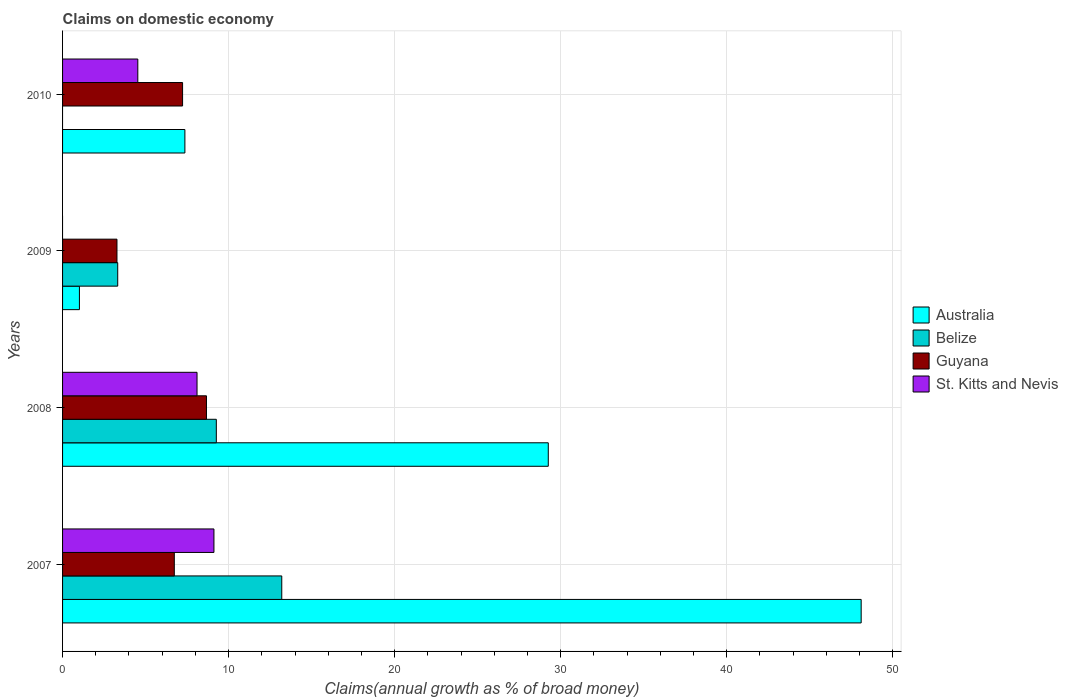Are the number of bars per tick equal to the number of legend labels?
Give a very brief answer. No. How many bars are there on the 4th tick from the top?
Your response must be concise. 4. How many bars are there on the 4th tick from the bottom?
Offer a very short reply. 3. What is the label of the 3rd group of bars from the top?
Your answer should be very brief. 2008. What is the percentage of broad money claimed on domestic economy in Belize in 2008?
Your answer should be very brief. 9.26. Across all years, what is the maximum percentage of broad money claimed on domestic economy in Guyana?
Provide a succinct answer. 8.67. Across all years, what is the minimum percentage of broad money claimed on domestic economy in Belize?
Offer a very short reply. 0. What is the total percentage of broad money claimed on domestic economy in Guyana in the graph?
Keep it short and to the point. 25.9. What is the difference between the percentage of broad money claimed on domestic economy in St. Kitts and Nevis in 2008 and that in 2010?
Your response must be concise. 3.57. What is the difference between the percentage of broad money claimed on domestic economy in Australia in 2008 and the percentage of broad money claimed on domestic economy in St. Kitts and Nevis in 2007?
Keep it short and to the point. 20.14. What is the average percentage of broad money claimed on domestic economy in St. Kitts and Nevis per year?
Your answer should be compact. 5.44. In the year 2007, what is the difference between the percentage of broad money claimed on domestic economy in St. Kitts and Nevis and percentage of broad money claimed on domestic economy in Australia?
Your response must be concise. -38.98. What is the ratio of the percentage of broad money claimed on domestic economy in Australia in 2007 to that in 2009?
Your answer should be compact. 47.4. Is the percentage of broad money claimed on domestic economy in Guyana in 2009 less than that in 2010?
Ensure brevity in your answer.  Yes. What is the difference between the highest and the second highest percentage of broad money claimed on domestic economy in Belize?
Keep it short and to the point. 3.94. What is the difference between the highest and the lowest percentage of broad money claimed on domestic economy in Belize?
Offer a very short reply. 13.2. In how many years, is the percentage of broad money claimed on domestic economy in Guyana greater than the average percentage of broad money claimed on domestic economy in Guyana taken over all years?
Your response must be concise. 3. Is it the case that in every year, the sum of the percentage of broad money claimed on domestic economy in Guyana and percentage of broad money claimed on domestic economy in St. Kitts and Nevis is greater than the sum of percentage of broad money claimed on domestic economy in Australia and percentage of broad money claimed on domestic economy in Belize?
Offer a terse response. No. Is it the case that in every year, the sum of the percentage of broad money claimed on domestic economy in Guyana and percentage of broad money claimed on domestic economy in St. Kitts and Nevis is greater than the percentage of broad money claimed on domestic economy in Belize?
Your answer should be very brief. No. How many bars are there?
Keep it short and to the point. 14. How many years are there in the graph?
Keep it short and to the point. 4. Are the values on the major ticks of X-axis written in scientific E-notation?
Ensure brevity in your answer.  No. How many legend labels are there?
Provide a succinct answer. 4. How are the legend labels stacked?
Give a very brief answer. Vertical. What is the title of the graph?
Provide a succinct answer. Claims on domestic economy. What is the label or title of the X-axis?
Offer a terse response. Claims(annual growth as % of broad money). What is the Claims(annual growth as % of broad money) of Australia in 2007?
Your answer should be compact. 48.1. What is the Claims(annual growth as % of broad money) of Belize in 2007?
Your answer should be very brief. 13.2. What is the Claims(annual growth as % of broad money) in Guyana in 2007?
Make the answer very short. 6.73. What is the Claims(annual growth as % of broad money) of St. Kitts and Nevis in 2007?
Your answer should be compact. 9.12. What is the Claims(annual growth as % of broad money) in Australia in 2008?
Make the answer very short. 29.25. What is the Claims(annual growth as % of broad money) of Belize in 2008?
Your response must be concise. 9.26. What is the Claims(annual growth as % of broad money) in Guyana in 2008?
Offer a terse response. 8.67. What is the Claims(annual growth as % of broad money) of St. Kitts and Nevis in 2008?
Keep it short and to the point. 8.1. What is the Claims(annual growth as % of broad money) in Australia in 2009?
Provide a short and direct response. 1.01. What is the Claims(annual growth as % of broad money) of Belize in 2009?
Provide a succinct answer. 3.32. What is the Claims(annual growth as % of broad money) of Guyana in 2009?
Provide a short and direct response. 3.28. What is the Claims(annual growth as % of broad money) of St. Kitts and Nevis in 2009?
Keep it short and to the point. 0. What is the Claims(annual growth as % of broad money) in Australia in 2010?
Provide a succinct answer. 7.37. What is the Claims(annual growth as % of broad money) of Belize in 2010?
Make the answer very short. 0. What is the Claims(annual growth as % of broad money) in Guyana in 2010?
Offer a terse response. 7.23. What is the Claims(annual growth as % of broad money) of St. Kitts and Nevis in 2010?
Make the answer very short. 4.53. Across all years, what is the maximum Claims(annual growth as % of broad money) in Australia?
Give a very brief answer. 48.1. Across all years, what is the maximum Claims(annual growth as % of broad money) in Belize?
Offer a very short reply. 13.2. Across all years, what is the maximum Claims(annual growth as % of broad money) in Guyana?
Your answer should be very brief. 8.67. Across all years, what is the maximum Claims(annual growth as % of broad money) in St. Kitts and Nevis?
Give a very brief answer. 9.12. Across all years, what is the minimum Claims(annual growth as % of broad money) of Australia?
Offer a terse response. 1.01. Across all years, what is the minimum Claims(annual growth as % of broad money) in Belize?
Your answer should be very brief. 0. Across all years, what is the minimum Claims(annual growth as % of broad money) of Guyana?
Your response must be concise. 3.28. What is the total Claims(annual growth as % of broad money) of Australia in the graph?
Give a very brief answer. 85.73. What is the total Claims(annual growth as % of broad money) of Belize in the graph?
Offer a terse response. 25.78. What is the total Claims(annual growth as % of broad money) in Guyana in the graph?
Provide a short and direct response. 25.9. What is the total Claims(annual growth as % of broad money) in St. Kitts and Nevis in the graph?
Keep it short and to the point. 21.75. What is the difference between the Claims(annual growth as % of broad money) of Australia in 2007 and that in 2008?
Keep it short and to the point. 18.84. What is the difference between the Claims(annual growth as % of broad money) of Belize in 2007 and that in 2008?
Offer a very short reply. 3.94. What is the difference between the Claims(annual growth as % of broad money) in Guyana in 2007 and that in 2008?
Your answer should be very brief. -1.94. What is the difference between the Claims(annual growth as % of broad money) of St. Kitts and Nevis in 2007 and that in 2008?
Give a very brief answer. 1.02. What is the difference between the Claims(annual growth as % of broad money) in Australia in 2007 and that in 2009?
Offer a terse response. 47.08. What is the difference between the Claims(annual growth as % of broad money) in Belize in 2007 and that in 2009?
Provide a short and direct response. 9.88. What is the difference between the Claims(annual growth as % of broad money) of Guyana in 2007 and that in 2009?
Provide a short and direct response. 3.45. What is the difference between the Claims(annual growth as % of broad money) in Australia in 2007 and that in 2010?
Give a very brief answer. 40.73. What is the difference between the Claims(annual growth as % of broad money) of Guyana in 2007 and that in 2010?
Your response must be concise. -0.5. What is the difference between the Claims(annual growth as % of broad money) in St. Kitts and Nevis in 2007 and that in 2010?
Keep it short and to the point. 4.59. What is the difference between the Claims(annual growth as % of broad money) of Australia in 2008 and that in 2009?
Your answer should be very brief. 28.24. What is the difference between the Claims(annual growth as % of broad money) of Belize in 2008 and that in 2009?
Keep it short and to the point. 5.94. What is the difference between the Claims(annual growth as % of broad money) of Guyana in 2008 and that in 2009?
Offer a terse response. 5.39. What is the difference between the Claims(annual growth as % of broad money) of Australia in 2008 and that in 2010?
Your response must be concise. 21.89. What is the difference between the Claims(annual growth as % of broad money) of Guyana in 2008 and that in 2010?
Give a very brief answer. 1.44. What is the difference between the Claims(annual growth as % of broad money) of St. Kitts and Nevis in 2008 and that in 2010?
Keep it short and to the point. 3.57. What is the difference between the Claims(annual growth as % of broad money) in Australia in 2009 and that in 2010?
Your answer should be compact. -6.35. What is the difference between the Claims(annual growth as % of broad money) of Guyana in 2009 and that in 2010?
Make the answer very short. -3.95. What is the difference between the Claims(annual growth as % of broad money) of Australia in 2007 and the Claims(annual growth as % of broad money) of Belize in 2008?
Offer a very short reply. 38.84. What is the difference between the Claims(annual growth as % of broad money) of Australia in 2007 and the Claims(annual growth as % of broad money) of Guyana in 2008?
Your response must be concise. 39.43. What is the difference between the Claims(annual growth as % of broad money) in Australia in 2007 and the Claims(annual growth as % of broad money) in St. Kitts and Nevis in 2008?
Provide a succinct answer. 40. What is the difference between the Claims(annual growth as % of broad money) of Belize in 2007 and the Claims(annual growth as % of broad money) of Guyana in 2008?
Give a very brief answer. 4.54. What is the difference between the Claims(annual growth as % of broad money) of Belize in 2007 and the Claims(annual growth as % of broad money) of St. Kitts and Nevis in 2008?
Your answer should be compact. 5.1. What is the difference between the Claims(annual growth as % of broad money) of Guyana in 2007 and the Claims(annual growth as % of broad money) of St. Kitts and Nevis in 2008?
Your answer should be compact. -1.37. What is the difference between the Claims(annual growth as % of broad money) in Australia in 2007 and the Claims(annual growth as % of broad money) in Belize in 2009?
Provide a succinct answer. 44.77. What is the difference between the Claims(annual growth as % of broad money) of Australia in 2007 and the Claims(annual growth as % of broad money) of Guyana in 2009?
Give a very brief answer. 44.82. What is the difference between the Claims(annual growth as % of broad money) of Belize in 2007 and the Claims(annual growth as % of broad money) of Guyana in 2009?
Make the answer very short. 9.93. What is the difference between the Claims(annual growth as % of broad money) in Australia in 2007 and the Claims(annual growth as % of broad money) in Guyana in 2010?
Your response must be concise. 40.87. What is the difference between the Claims(annual growth as % of broad money) of Australia in 2007 and the Claims(annual growth as % of broad money) of St. Kitts and Nevis in 2010?
Offer a terse response. 43.56. What is the difference between the Claims(annual growth as % of broad money) of Belize in 2007 and the Claims(annual growth as % of broad money) of Guyana in 2010?
Your answer should be very brief. 5.97. What is the difference between the Claims(annual growth as % of broad money) in Belize in 2007 and the Claims(annual growth as % of broad money) in St. Kitts and Nevis in 2010?
Your response must be concise. 8.67. What is the difference between the Claims(annual growth as % of broad money) of Guyana in 2007 and the Claims(annual growth as % of broad money) of St. Kitts and Nevis in 2010?
Offer a very short reply. 2.2. What is the difference between the Claims(annual growth as % of broad money) in Australia in 2008 and the Claims(annual growth as % of broad money) in Belize in 2009?
Ensure brevity in your answer.  25.93. What is the difference between the Claims(annual growth as % of broad money) of Australia in 2008 and the Claims(annual growth as % of broad money) of Guyana in 2009?
Give a very brief answer. 25.98. What is the difference between the Claims(annual growth as % of broad money) of Belize in 2008 and the Claims(annual growth as % of broad money) of Guyana in 2009?
Your answer should be very brief. 5.98. What is the difference between the Claims(annual growth as % of broad money) in Australia in 2008 and the Claims(annual growth as % of broad money) in Guyana in 2010?
Your answer should be compact. 22.02. What is the difference between the Claims(annual growth as % of broad money) of Australia in 2008 and the Claims(annual growth as % of broad money) of St. Kitts and Nevis in 2010?
Provide a short and direct response. 24.72. What is the difference between the Claims(annual growth as % of broad money) of Belize in 2008 and the Claims(annual growth as % of broad money) of Guyana in 2010?
Offer a terse response. 2.03. What is the difference between the Claims(annual growth as % of broad money) in Belize in 2008 and the Claims(annual growth as % of broad money) in St. Kitts and Nevis in 2010?
Your answer should be very brief. 4.73. What is the difference between the Claims(annual growth as % of broad money) in Guyana in 2008 and the Claims(annual growth as % of broad money) in St. Kitts and Nevis in 2010?
Your response must be concise. 4.13. What is the difference between the Claims(annual growth as % of broad money) in Australia in 2009 and the Claims(annual growth as % of broad money) in Guyana in 2010?
Keep it short and to the point. -6.21. What is the difference between the Claims(annual growth as % of broad money) in Australia in 2009 and the Claims(annual growth as % of broad money) in St. Kitts and Nevis in 2010?
Keep it short and to the point. -3.52. What is the difference between the Claims(annual growth as % of broad money) in Belize in 2009 and the Claims(annual growth as % of broad money) in Guyana in 2010?
Ensure brevity in your answer.  -3.91. What is the difference between the Claims(annual growth as % of broad money) in Belize in 2009 and the Claims(annual growth as % of broad money) in St. Kitts and Nevis in 2010?
Your answer should be compact. -1.21. What is the difference between the Claims(annual growth as % of broad money) in Guyana in 2009 and the Claims(annual growth as % of broad money) in St. Kitts and Nevis in 2010?
Keep it short and to the point. -1.26. What is the average Claims(annual growth as % of broad money) of Australia per year?
Your answer should be compact. 21.43. What is the average Claims(annual growth as % of broad money) of Belize per year?
Provide a short and direct response. 6.45. What is the average Claims(annual growth as % of broad money) in Guyana per year?
Offer a very short reply. 6.48. What is the average Claims(annual growth as % of broad money) of St. Kitts and Nevis per year?
Keep it short and to the point. 5.44. In the year 2007, what is the difference between the Claims(annual growth as % of broad money) in Australia and Claims(annual growth as % of broad money) in Belize?
Offer a terse response. 34.89. In the year 2007, what is the difference between the Claims(annual growth as % of broad money) of Australia and Claims(annual growth as % of broad money) of Guyana?
Your answer should be compact. 41.37. In the year 2007, what is the difference between the Claims(annual growth as % of broad money) of Australia and Claims(annual growth as % of broad money) of St. Kitts and Nevis?
Keep it short and to the point. 38.98. In the year 2007, what is the difference between the Claims(annual growth as % of broad money) in Belize and Claims(annual growth as % of broad money) in Guyana?
Make the answer very short. 6.47. In the year 2007, what is the difference between the Claims(annual growth as % of broad money) of Belize and Claims(annual growth as % of broad money) of St. Kitts and Nevis?
Provide a succinct answer. 4.08. In the year 2007, what is the difference between the Claims(annual growth as % of broad money) in Guyana and Claims(annual growth as % of broad money) in St. Kitts and Nevis?
Make the answer very short. -2.39. In the year 2008, what is the difference between the Claims(annual growth as % of broad money) in Australia and Claims(annual growth as % of broad money) in Belize?
Your answer should be compact. 19.99. In the year 2008, what is the difference between the Claims(annual growth as % of broad money) in Australia and Claims(annual growth as % of broad money) in Guyana?
Offer a terse response. 20.59. In the year 2008, what is the difference between the Claims(annual growth as % of broad money) of Australia and Claims(annual growth as % of broad money) of St. Kitts and Nevis?
Ensure brevity in your answer.  21.15. In the year 2008, what is the difference between the Claims(annual growth as % of broad money) in Belize and Claims(annual growth as % of broad money) in Guyana?
Ensure brevity in your answer.  0.59. In the year 2008, what is the difference between the Claims(annual growth as % of broad money) in Belize and Claims(annual growth as % of broad money) in St. Kitts and Nevis?
Ensure brevity in your answer.  1.16. In the year 2008, what is the difference between the Claims(annual growth as % of broad money) of Guyana and Claims(annual growth as % of broad money) of St. Kitts and Nevis?
Your answer should be compact. 0.57. In the year 2009, what is the difference between the Claims(annual growth as % of broad money) of Australia and Claims(annual growth as % of broad money) of Belize?
Give a very brief answer. -2.31. In the year 2009, what is the difference between the Claims(annual growth as % of broad money) in Australia and Claims(annual growth as % of broad money) in Guyana?
Give a very brief answer. -2.26. In the year 2009, what is the difference between the Claims(annual growth as % of broad money) in Belize and Claims(annual growth as % of broad money) in Guyana?
Offer a terse response. 0.05. In the year 2010, what is the difference between the Claims(annual growth as % of broad money) in Australia and Claims(annual growth as % of broad money) in Guyana?
Keep it short and to the point. 0.14. In the year 2010, what is the difference between the Claims(annual growth as % of broad money) of Australia and Claims(annual growth as % of broad money) of St. Kitts and Nevis?
Your answer should be compact. 2.84. In the year 2010, what is the difference between the Claims(annual growth as % of broad money) in Guyana and Claims(annual growth as % of broad money) in St. Kitts and Nevis?
Offer a terse response. 2.7. What is the ratio of the Claims(annual growth as % of broad money) in Australia in 2007 to that in 2008?
Give a very brief answer. 1.64. What is the ratio of the Claims(annual growth as % of broad money) in Belize in 2007 to that in 2008?
Keep it short and to the point. 1.43. What is the ratio of the Claims(annual growth as % of broad money) of Guyana in 2007 to that in 2008?
Ensure brevity in your answer.  0.78. What is the ratio of the Claims(annual growth as % of broad money) in St. Kitts and Nevis in 2007 to that in 2008?
Your response must be concise. 1.13. What is the ratio of the Claims(annual growth as % of broad money) of Australia in 2007 to that in 2009?
Provide a succinct answer. 47.4. What is the ratio of the Claims(annual growth as % of broad money) of Belize in 2007 to that in 2009?
Provide a succinct answer. 3.97. What is the ratio of the Claims(annual growth as % of broad money) of Guyana in 2007 to that in 2009?
Provide a short and direct response. 2.05. What is the ratio of the Claims(annual growth as % of broad money) in Australia in 2007 to that in 2010?
Give a very brief answer. 6.53. What is the ratio of the Claims(annual growth as % of broad money) of Guyana in 2007 to that in 2010?
Keep it short and to the point. 0.93. What is the ratio of the Claims(annual growth as % of broad money) of St. Kitts and Nevis in 2007 to that in 2010?
Keep it short and to the point. 2.01. What is the ratio of the Claims(annual growth as % of broad money) of Australia in 2008 to that in 2009?
Make the answer very short. 28.83. What is the ratio of the Claims(annual growth as % of broad money) of Belize in 2008 to that in 2009?
Your answer should be compact. 2.79. What is the ratio of the Claims(annual growth as % of broad money) in Guyana in 2008 to that in 2009?
Your answer should be compact. 2.65. What is the ratio of the Claims(annual growth as % of broad money) in Australia in 2008 to that in 2010?
Your answer should be compact. 3.97. What is the ratio of the Claims(annual growth as % of broad money) of Guyana in 2008 to that in 2010?
Provide a short and direct response. 1.2. What is the ratio of the Claims(annual growth as % of broad money) in St. Kitts and Nevis in 2008 to that in 2010?
Ensure brevity in your answer.  1.79. What is the ratio of the Claims(annual growth as % of broad money) of Australia in 2009 to that in 2010?
Provide a short and direct response. 0.14. What is the ratio of the Claims(annual growth as % of broad money) of Guyana in 2009 to that in 2010?
Offer a very short reply. 0.45. What is the difference between the highest and the second highest Claims(annual growth as % of broad money) in Australia?
Make the answer very short. 18.84. What is the difference between the highest and the second highest Claims(annual growth as % of broad money) of Belize?
Your answer should be very brief. 3.94. What is the difference between the highest and the second highest Claims(annual growth as % of broad money) in Guyana?
Offer a terse response. 1.44. What is the difference between the highest and the second highest Claims(annual growth as % of broad money) of St. Kitts and Nevis?
Offer a terse response. 1.02. What is the difference between the highest and the lowest Claims(annual growth as % of broad money) in Australia?
Offer a terse response. 47.08. What is the difference between the highest and the lowest Claims(annual growth as % of broad money) of Belize?
Ensure brevity in your answer.  13.2. What is the difference between the highest and the lowest Claims(annual growth as % of broad money) in Guyana?
Your answer should be very brief. 5.39. What is the difference between the highest and the lowest Claims(annual growth as % of broad money) in St. Kitts and Nevis?
Keep it short and to the point. 9.12. 